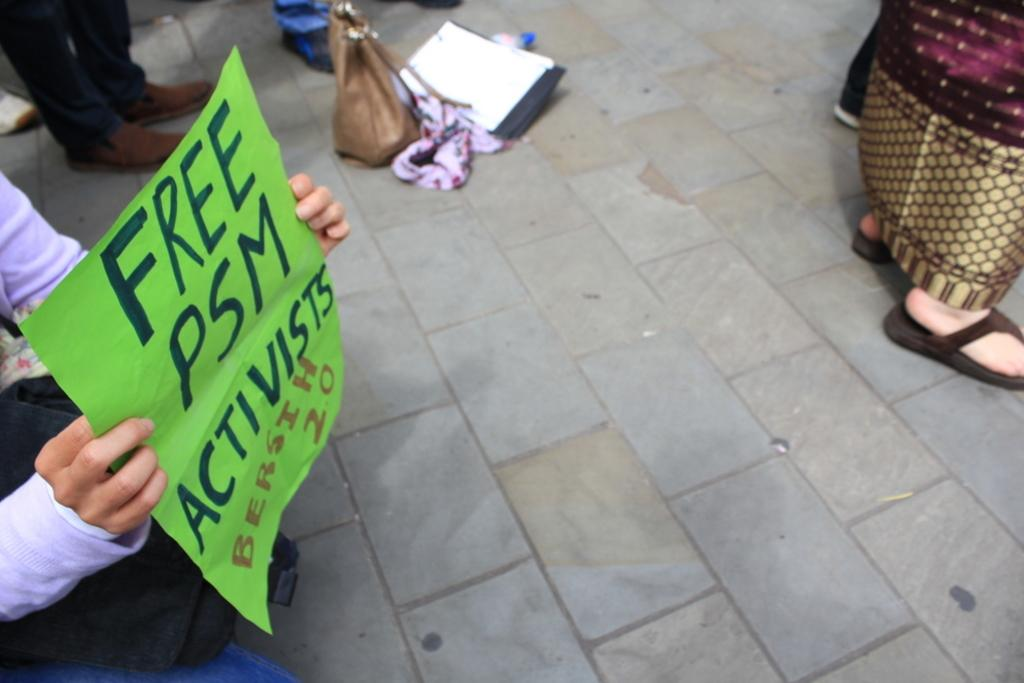What is the person in the image doing? The person is holding a poster in the image. What can be seen beneath the person's feet? There is a floor visible in the image. What else is present in the image besides the person and the poster? There is a bag in the image. What type of milk is being advertised on the poster in the image? There is no milk or advertisement present on the poster in the image; it only shows a person holding a poster. What type of property is being sold in the image? There is no property being sold in the image; it only shows a person holding a poster and a bag. 